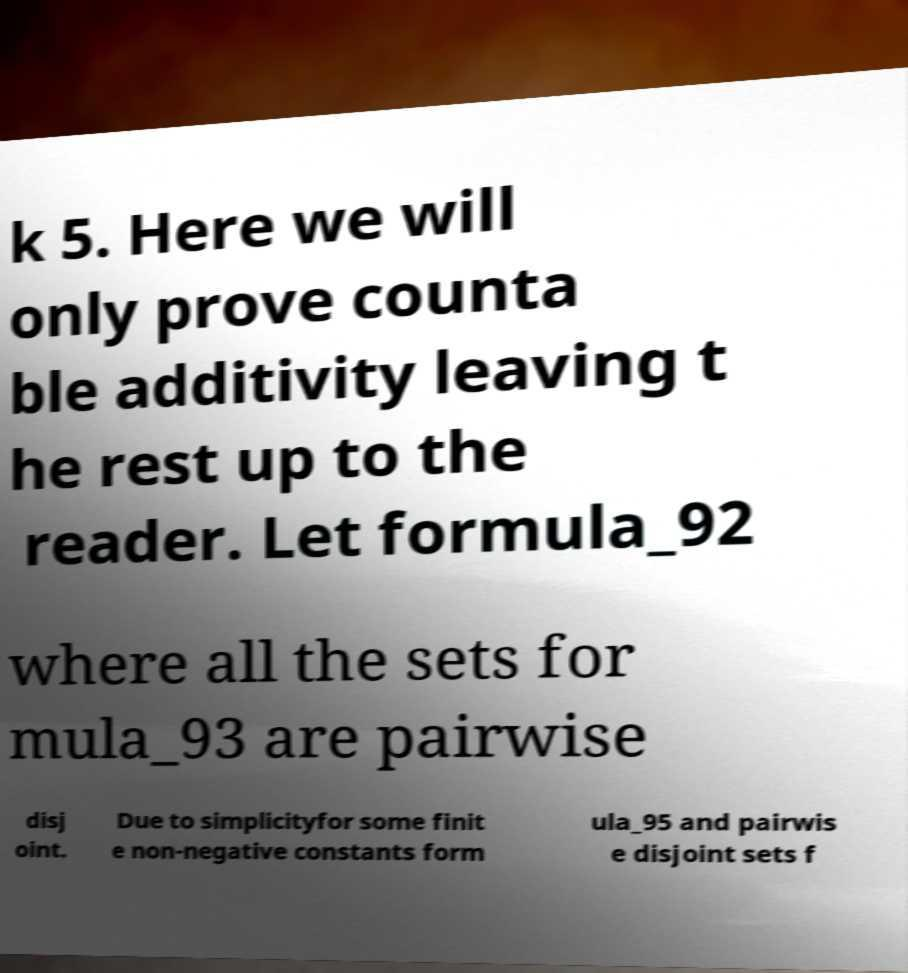Could you extract and type out the text from this image? k 5. Here we will only prove counta ble additivity leaving t he rest up to the reader. Let formula_92 where all the sets for mula_93 are pairwise disj oint. Due to simplicityfor some finit e non-negative constants form ula_95 and pairwis e disjoint sets f 